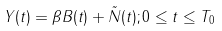<formula> <loc_0><loc_0><loc_500><loc_500>Y ( t ) = \beta B ( t ) + \tilde { N } ( t ) ; 0 \leq t \leq T _ { 0 }</formula> 